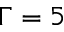<formula> <loc_0><loc_0><loc_500><loc_500>\Gamma = 5</formula> 